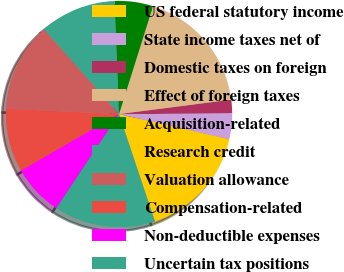<chart> <loc_0><loc_0><loc_500><loc_500><pie_chart><fcel>US federal statutory income<fcel>State income taxes net of<fcel>Domestic taxes on foreign<fcel>Effect of foreign taxes<fcel>Acquisition-related<fcel>Research credit<fcel>Valuation allowance<fcel>Compensation-related<fcel>Non-deductible expenses<fcel>Uncertain tax positions<nl><fcel>16.3%<fcel>3.7%<fcel>1.89%<fcel>18.11%<fcel>5.5%<fcel>10.9%<fcel>12.7%<fcel>9.1%<fcel>7.3%<fcel>14.5%<nl></chart> 